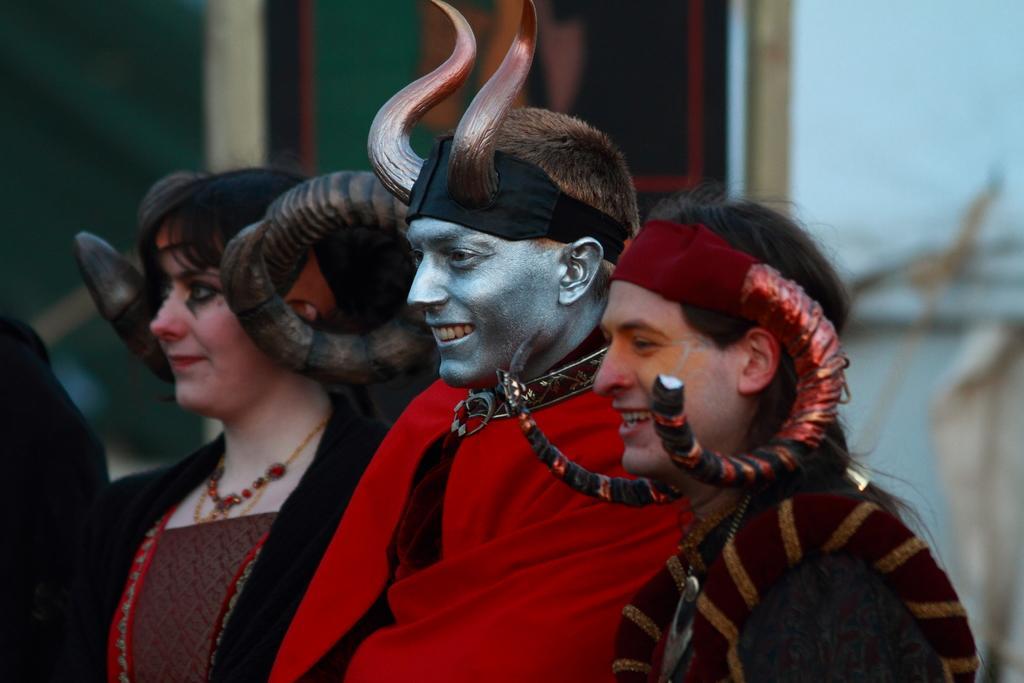Please provide a concise description of this image. There are people standing. Background we can see wall. 